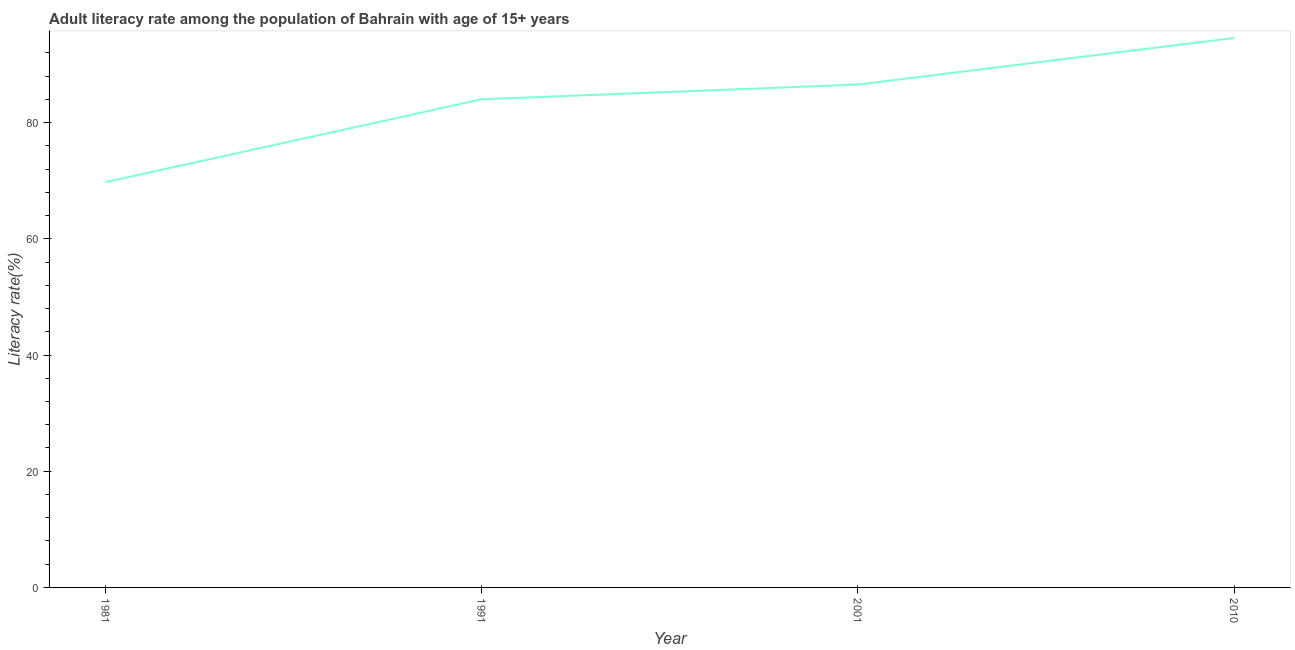What is the adult literacy rate in 2010?
Give a very brief answer. 94.56. Across all years, what is the maximum adult literacy rate?
Give a very brief answer. 94.56. Across all years, what is the minimum adult literacy rate?
Your answer should be very brief. 69.75. What is the sum of the adult literacy rate?
Make the answer very short. 334.87. What is the difference between the adult literacy rate in 1981 and 2001?
Offer a terse response. -16.8. What is the average adult literacy rate per year?
Give a very brief answer. 83.72. What is the median adult literacy rate?
Offer a terse response. 85.28. In how many years, is the adult literacy rate greater than 60 %?
Your response must be concise. 4. Do a majority of the years between 1981 and 1991 (inclusive) have adult literacy rate greater than 52 %?
Keep it short and to the point. Yes. What is the ratio of the adult literacy rate in 1981 to that in 2010?
Your answer should be compact. 0.74. Is the difference between the adult literacy rate in 2001 and 2010 greater than the difference between any two years?
Offer a terse response. No. What is the difference between the highest and the second highest adult literacy rate?
Provide a short and direct response. 8.01. What is the difference between the highest and the lowest adult literacy rate?
Ensure brevity in your answer.  24.8. How many lines are there?
Keep it short and to the point. 1. How many years are there in the graph?
Your answer should be compact. 4. Are the values on the major ticks of Y-axis written in scientific E-notation?
Offer a terse response. No. Does the graph contain any zero values?
Keep it short and to the point. No. What is the title of the graph?
Your answer should be compact. Adult literacy rate among the population of Bahrain with age of 15+ years. What is the label or title of the X-axis?
Ensure brevity in your answer.  Year. What is the label or title of the Y-axis?
Provide a succinct answer. Literacy rate(%). What is the Literacy rate(%) of 1981?
Provide a succinct answer. 69.75. What is the Literacy rate(%) of 1991?
Offer a terse response. 84.01. What is the Literacy rate(%) in 2001?
Ensure brevity in your answer.  86.55. What is the Literacy rate(%) of 2010?
Offer a very short reply. 94.56. What is the difference between the Literacy rate(%) in 1981 and 1991?
Provide a succinct answer. -14.26. What is the difference between the Literacy rate(%) in 1981 and 2001?
Offer a terse response. -16.8. What is the difference between the Literacy rate(%) in 1981 and 2010?
Your answer should be very brief. -24.8. What is the difference between the Literacy rate(%) in 1991 and 2001?
Provide a succinct answer. -2.53. What is the difference between the Literacy rate(%) in 1991 and 2010?
Keep it short and to the point. -10.54. What is the difference between the Literacy rate(%) in 2001 and 2010?
Offer a very short reply. -8.01. What is the ratio of the Literacy rate(%) in 1981 to that in 1991?
Provide a short and direct response. 0.83. What is the ratio of the Literacy rate(%) in 1981 to that in 2001?
Give a very brief answer. 0.81. What is the ratio of the Literacy rate(%) in 1981 to that in 2010?
Provide a short and direct response. 0.74. What is the ratio of the Literacy rate(%) in 1991 to that in 2010?
Offer a terse response. 0.89. What is the ratio of the Literacy rate(%) in 2001 to that in 2010?
Make the answer very short. 0.92. 